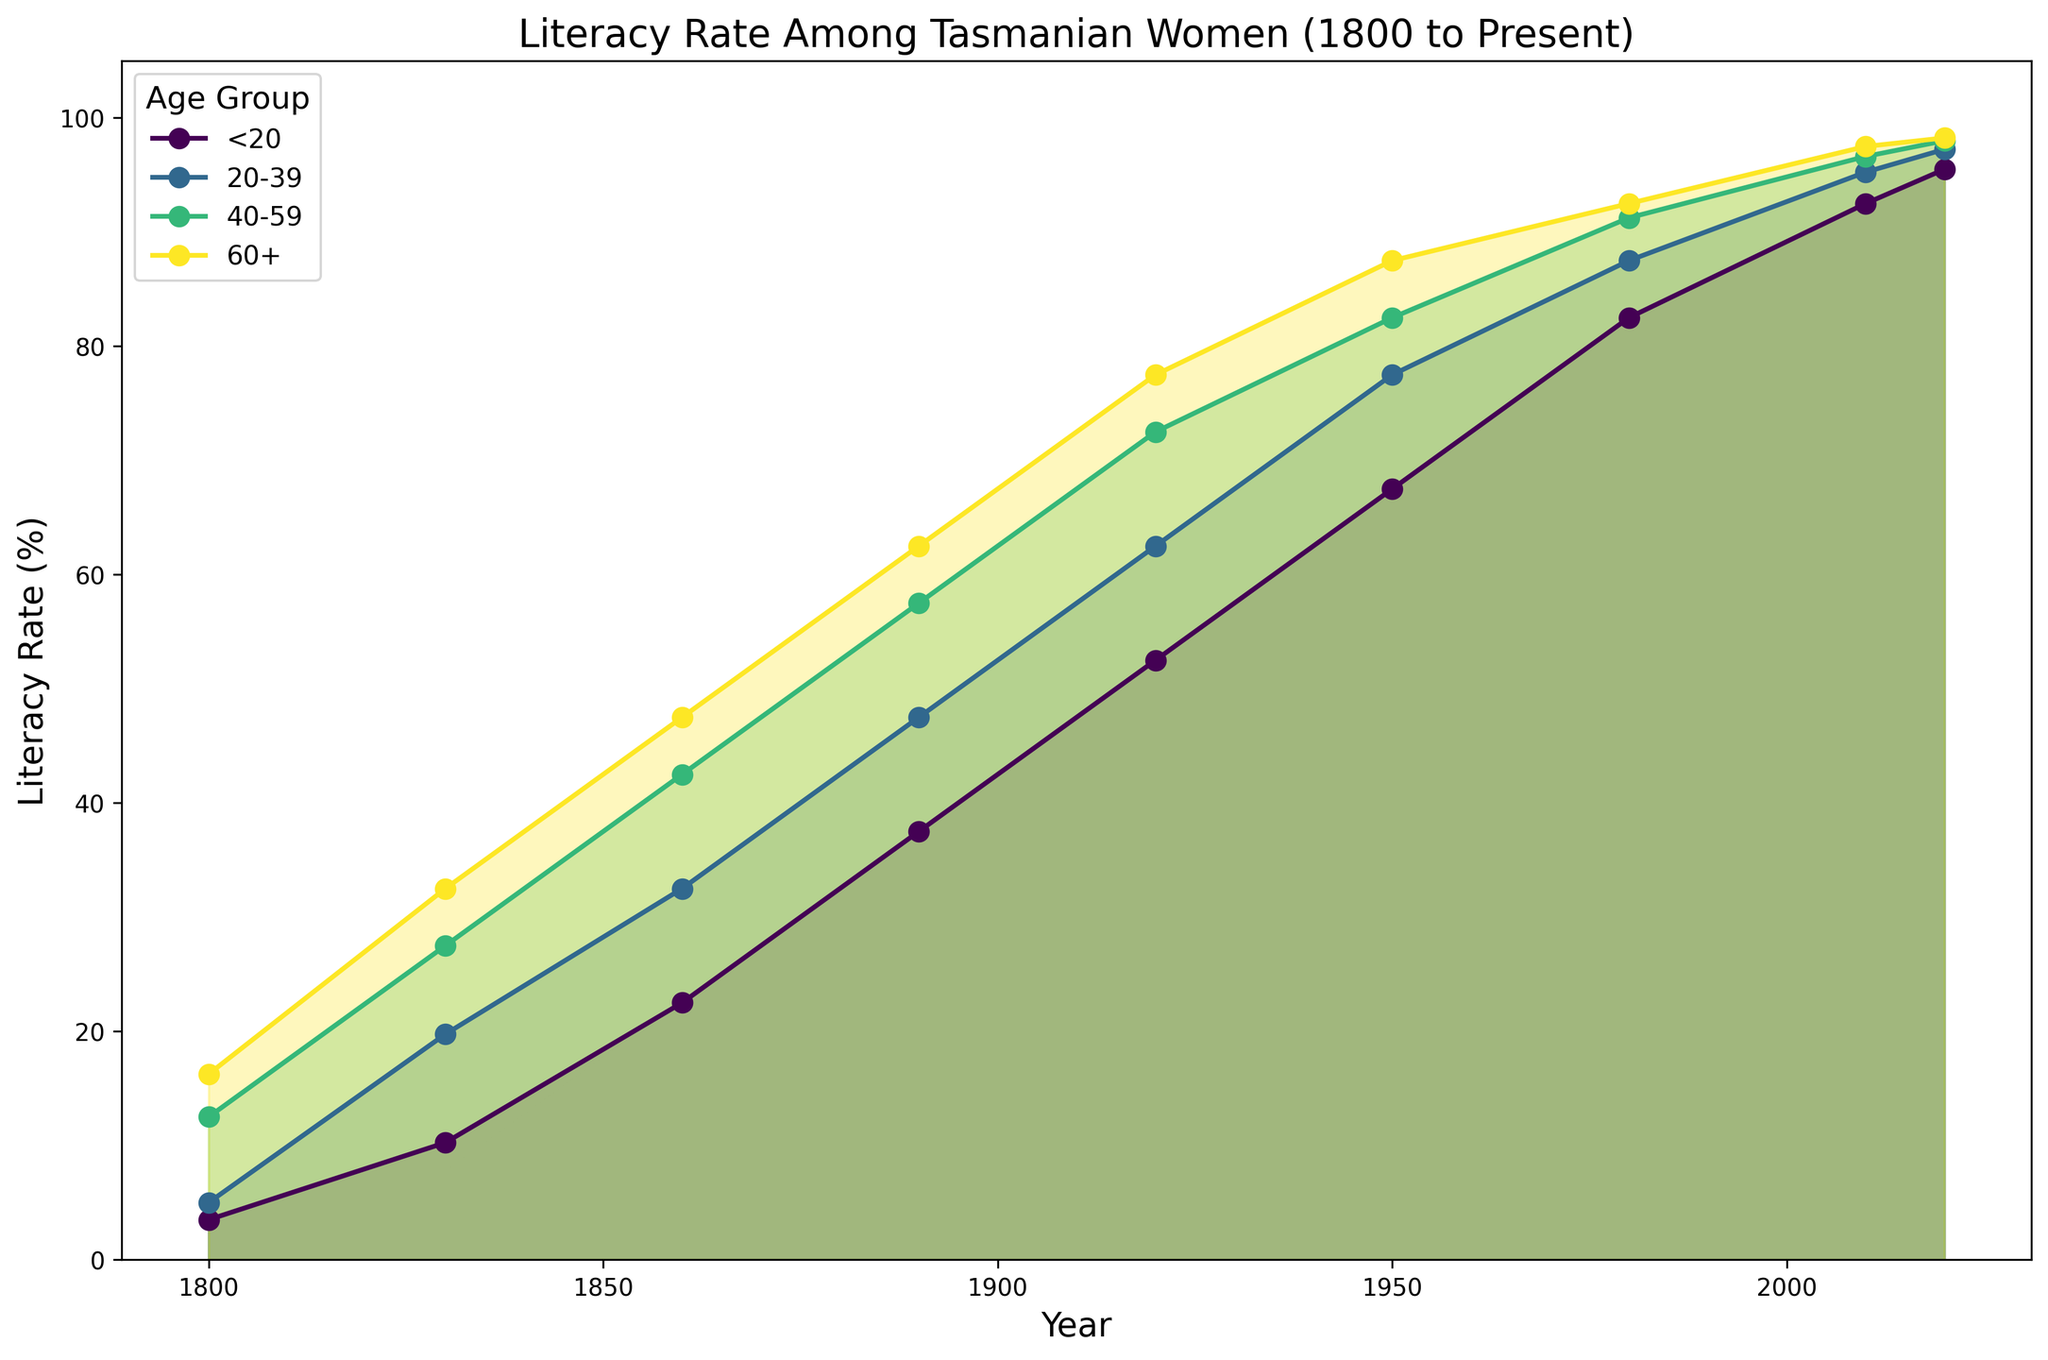How has the literacy rate for the age group 20-39 changed from 1800 to 2020? To determine the change in the literacy rate for the 20-39 age group from 1800 to 2020, we observe their positions on the y-axis at these two time points. In 1800, the rate is around 6, while in 2020, it reaches 99. This indicates a significant increase over time.
Answer: From around 6% to 99% Which age group had the highest literacy rate in 1830? To find the age group with the highest literacy rate in 1830, we compare the rates visually. The 60+ age group has the highest rate, as their line is the highest on the y-axis at this point.
Answer: 60+ Between which years did the age group <20 see the most significant increase in literacy rate? We need to identify the year range where the <20 age group’s line shows the steepest upward slope. The period from 1980 to 2010 shows a noticeable sharp increase, suggesting this was when the literacy rate grew the most rapidly.
Answer: 1980 to 2010 Compare the average literacy rates for the age group 40-59 across all the years. First, look at the 40-59 series across all years and average their values: (15+25+40+55+70+85+90+97+100) / 9 = 63.
Answer: 63% Which age group showed the smallest increase in literacy rate from 1860 to 1920? Observing the y-axis positions for each age group from 1860 to 1920, the 60+ age group’s lines show the smallest increase from 40 to 70, compared to others.
Answer: 60+ Which age group reached a 100% literacy rate first? Identify the first occurrence of 100% literacy in any age group. The age group 60+ reached it by 2010.
Answer: 60+ in 2010 In 1980, how did the literacy rate for the age group 60+ compare to the rate for the age group 20-39? In 1980, the literacy rate for the 60+ age group was around 90, while the rate for the 20-39 age group was approximately 95.
Answer: The rate for 60+ was lower than 20-39 How did the literacy rates among all categories of age groups change from 1950 to 1980? We compare the literacy rates for each age group in 1950 and 1980. All age groups show a significant increase: <20 (75 to 90), 20-39 (85 to 95), 40-59 (90 to 97), and 60+ (95 to 98).
Answer: All increased Compare the literacy improvement for 60+ age group from 1860 to 2020. The literacy rate for 60+ in 1860 was 40 and increased to 100 by 2020, showing a significant improvement.
Answer: From 40% to 100% Which age group has consistently higher literacy rates across all years? By observing the graph, the 60+ age group consistently maintains the highest literacy rates throughout the recorded years.
Answer: 60+ 